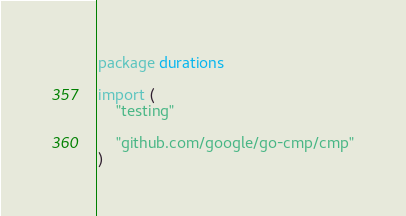<code> <loc_0><loc_0><loc_500><loc_500><_Go_>package durations

import (
	"testing"

	"github.com/google/go-cmp/cmp"
)
</code> 